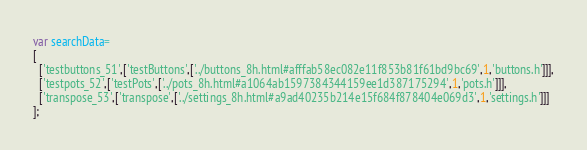Convert code to text. <code><loc_0><loc_0><loc_500><loc_500><_JavaScript_>var searchData=
[
  ['testbuttons_51',['testButtons',['../buttons_8h.html#afffab58ec082e11f853b81f61bd9bc69',1,'buttons.h']]],
  ['testpots_52',['testPots',['../pots_8h.html#a1064ab1597384344159ee1d387175294',1,'pots.h']]],
  ['transpose_53',['transpose',['../settings_8h.html#a9ad40235b214e15f684f878404e069d3',1,'settings.h']]]
];
</code> 